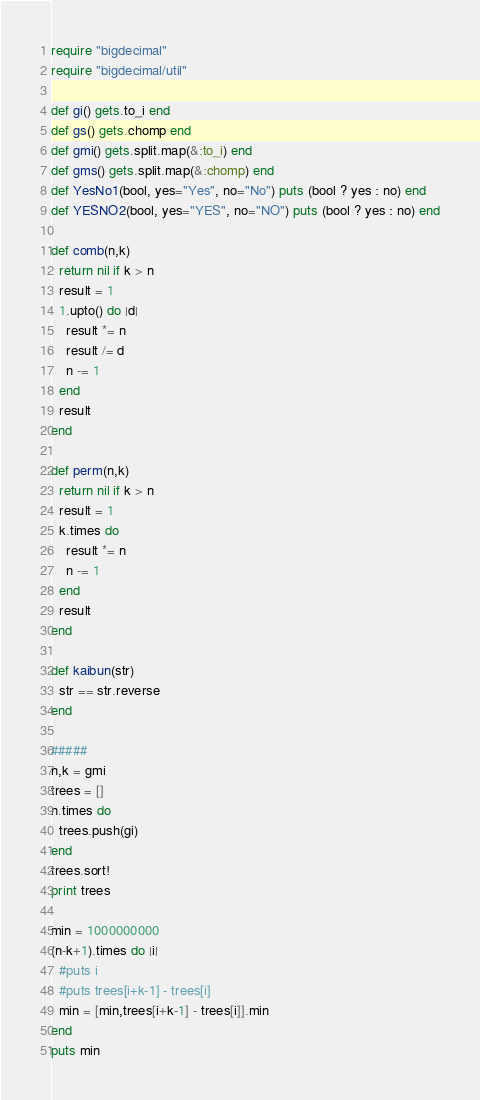Convert code to text. <code><loc_0><loc_0><loc_500><loc_500><_Ruby_>require "bigdecimal"
require "bigdecimal/util"

def gi() gets.to_i end
def gs() gets.chomp end
def gmi() gets.split.map(&:to_i) end
def gms() gets.split.map(&:chomp) end
def YesNo1(bool, yes="Yes", no="No") puts (bool ? yes : no) end
def YESNO2(bool, yes="YES", no="NO") puts (bool ? yes : no) end

def comb(n,k)
  return nil if k > n
  result = 1
  1.upto() do |d|
    result *= n
    result /= d
    n -= 1
  end
  result
end

def perm(n,k)
  return nil if k > n
  result = 1
  k.times do
    result *= n
    n -= 1
  end
  result
end

def kaibun(str)
  str == str.reverse
end

#####
n,k = gmi
trees = []
n.times do
  trees.push(gi)
end
trees.sort!
print trees

min = 1000000000
(n-k+1).times do |i|
  #puts i
  #puts trees[i+k-1] - trees[i]
  min = [min,trees[i+k-1] - trees[i]].min
end
puts min</code> 